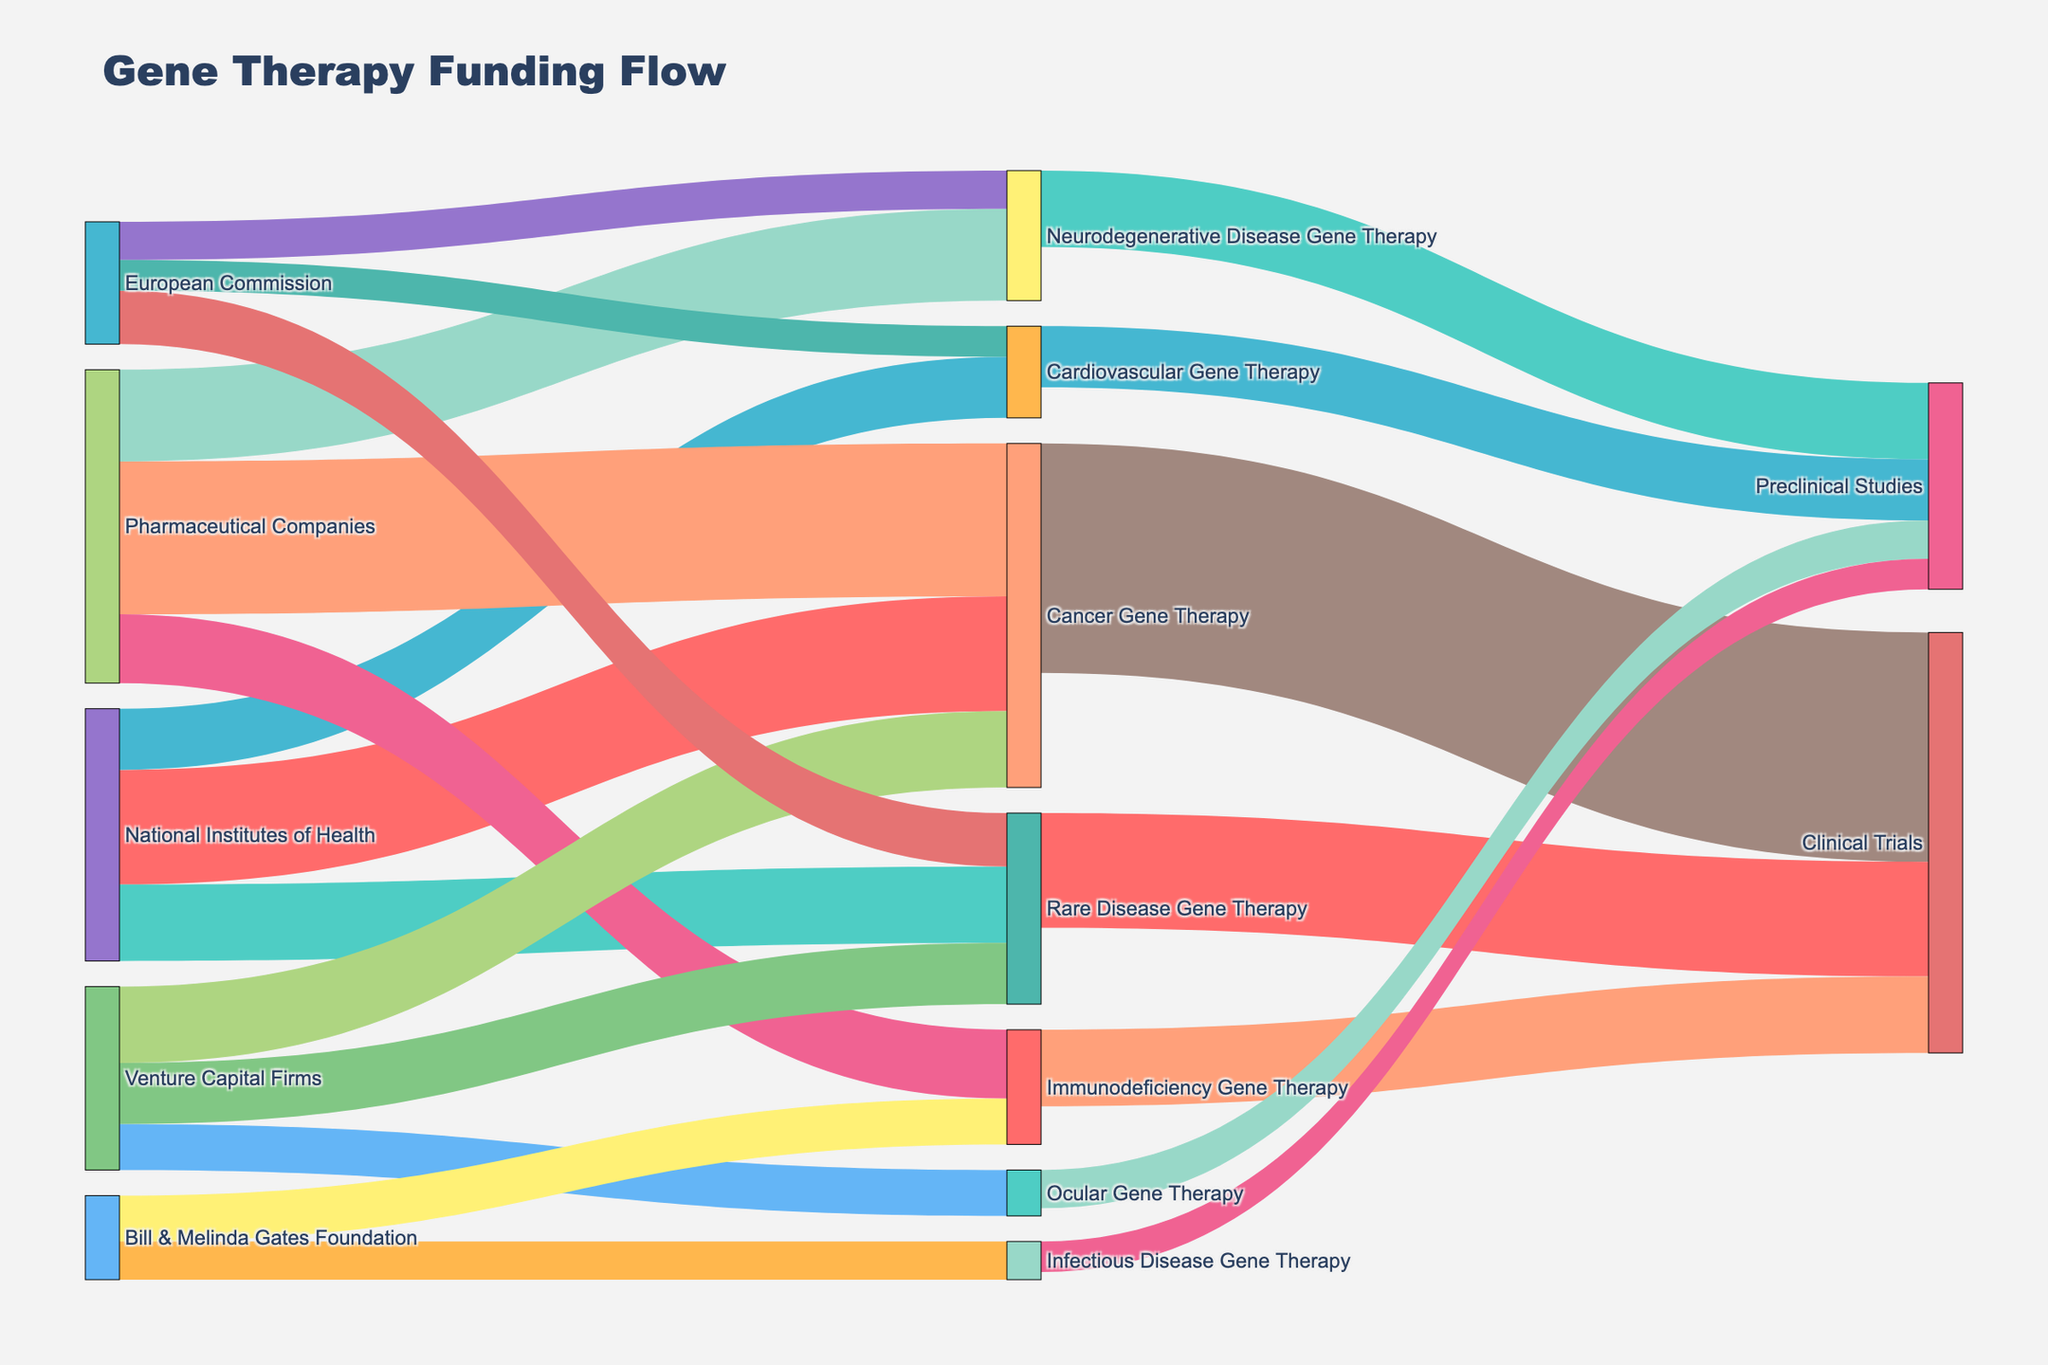Which funding source allocates the most funds to Cancer Gene Therapy? By examining the source links leading to "Cancer Gene Therapy," we see the highest allocation comes from "Pharmaceutical Companies" with a value of 200.
Answer: Pharmaceutical Companies What is the total funding allocated to Neurodegenerative Disease Gene Therapy? Sum the funding amounts from both sources to "Neurodegenerative Disease Gene Therapy" which are 120 (Pharmaceutical Companies) and 50 (European Commission), totaling 170.
Answer: 170 Which research area receives the least amount of funding from the National Institutes of Health? Reviewing the links originating from "National Institutes of Health," we find "Cardiovascular Gene Therapy" receives the lowest amount at 80.
Answer: Cardiovascular Gene Therapy How much total funding does Immunodeficiency Gene Therapy receive? Add the funding from both sources to "Immunodeficiency Gene Therapy," which are 90 (Pharmaceutical Companies) and 60 (Bill & Melinda Gates Foundation), resulting in 150.
Answer: 150 Which areas of gene therapy are funded by the Bill & Melinda Gates Foundation? By checking the links from "Bill & Melinda Gates Foundation," we find funding is allocated to "Immunodeficiency Gene Therapy" and "Infectious Disease Gene Therapy."
Answer: Immunodeficiency Gene Therapy, Infectious Disease Gene Therapy How does the amount of funding from Venture Capital Firms to Ocular Gene Therapy compare to that from the European Commission to Cardiovascular Gene Therapy? Venture Capital Firms allocate 60 to "Ocular Gene Therapy," while the European Commission allocates 40 to "Cardiovascular Gene Therapy." Since 60 > 40, Venture Capital Firms provide more.
Answer: Venture Capital Firms provide more What is the total funding allocated to Rare Disease Gene Therapy? Sum the funding amounts from all sources to "Rare Disease Gene Therapy," which are 100 (National Institutes of Health), 80 (Venture Capital Firms), and 70 (European Commission), totaling 250.
Answer: 250 Which research area receives the highest funding from the National Institutes of Health? By comparing the values for each research area funded by the "National Institutes of Health," "Cancer Gene Therapy" receives the highest funding at 150.
Answer: Cancer Gene Therapy What is the total funding allocated to research areas that include preclinical studies? Sum the funds allocated to areas marked with preclinical studies: 100 (Neurodegenerative Disease Gene Therapy), 80 (Cardiovascular Gene Therapy), 50 (Ocular Gene Therapy), and 40 (Infectious Disease Gene Therapy), totaling 270.
Answer: 270 